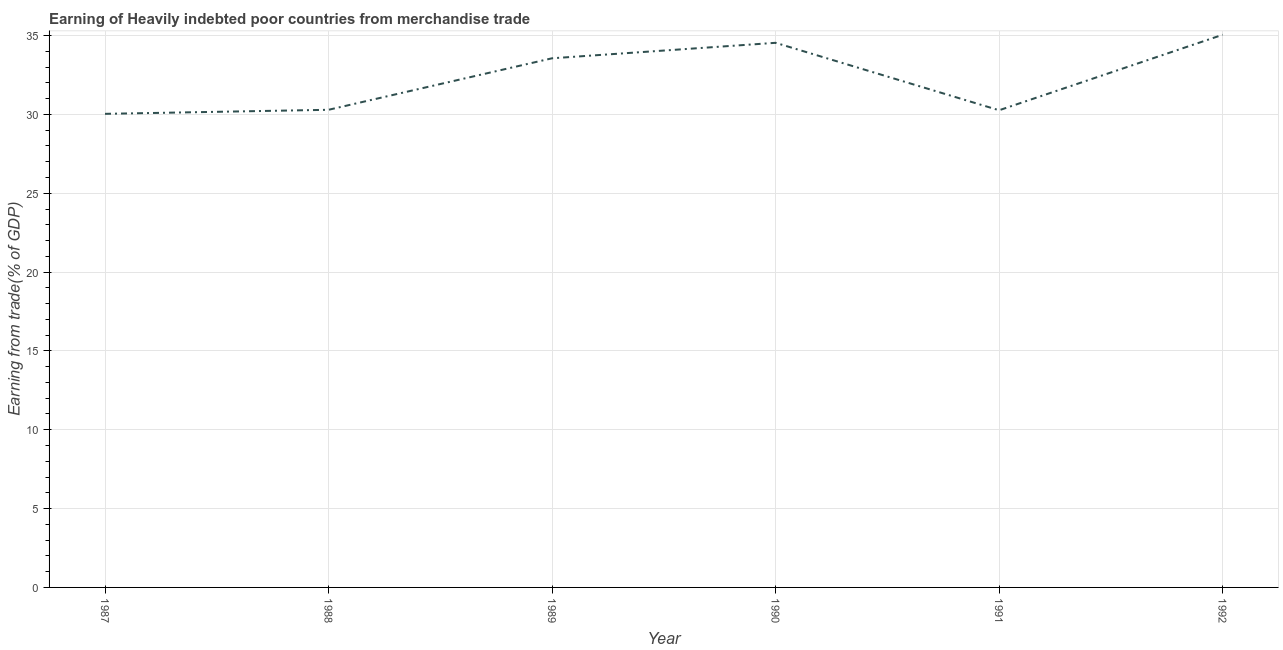What is the earning from merchandise trade in 1991?
Your answer should be very brief. 30.26. Across all years, what is the maximum earning from merchandise trade?
Offer a terse response. 35.05. Across all years, what is the minimum earning from merchandise trade?
Keep it short and to the point. 30.03. In which year was the earning from merchandise trade maximum?
Keep it short and to the point. 1992. In which year was the earning from merchandise trade minimum?
Make the answer very short. 1987. What is the sum of the earning from merchandise trade?
Keep it short and to the point. 193.74. What is the difference between the earning from merchandise trade in 1988 and 1990?
Offer a very short reply. -4.25. What is the average earning from merchandise trade per year?
Your answer should be compact. 32.29. What is the median earning from merchandise trade?
Your answer should be very brief. 31.93. In how many years, is the earning from merchandise trade greater than 25 %?
Make the answer very short. 6. What is the ratio of the earning from merchandise trade in 1988 to that in 1989?
Your response must be concise. 0.9. Is the earning from merchandise trade in 1988 less than that in 1992?
Your answer should be compact. Yes. Is the difference between the earning from merchandise trade in 1987 and 1989 greater than the difference between any two years?
Make the answer very short. No. What is the difference between the highest and the second highest earning from merchandise trade?
Ensure brevity in your answer.  0.51. What is the difference between the highest and the lowest earning from merchandise trade?
Make the answer very short. 5.01. Does the earning from merchandise trade monotonically increase over the years?
Offer a terse response. No. How many years are there in the graph?
Provide a short and direct response. 6. Does the graph contain any zero values?
Offer a terse response. No. What is the title of the graph?
Make the answer very short. Earning of Heavily indebted poor countries from merchandise trade. What is the label or title of the X-axis?
Provide a succinct answer. Year. What is the label or title of the Y-axis?
Ensure brevity in your answer.  Earning from trade(% of GDP). What is the Earning from trade(% of GDP) of 1987?
Offer a terse response. 30.03. What is the Earning from trade(% of GDP) of 1988?
Provide a short and direct response. 30.29. What is the Earning from trade(% of GDP) of 1989?
Provide a short and direct response. 33.56. What is the Earning from trade(% of GDP) of 1990?
Ensure brevity in your answer.  34.54. What is the Earning from trade(% of GDP) of 1991?
Make the answer very short. 30.26. What is the Earning from trade(% of GDP) of 1992?
Provide a succinct answer. 35.05. What is the difference between the Earning from trade(% of GDP) in 1987 and 1988?
Your response must be concise. -0.26. What is the difference between the Earning from trade(% of GDP) in 1987 and 1989?
Your answer should be very brief. -3.52. What is the difference between the Earning from trade(% of GDP) in 1987 and 1990?
Provide a succinct answer. -4.51. What is the difference between the Earning from trade(% of GDP) in 1987 and 1991?
Your response must be concise. -0.23. What is the difference between the Earning from trade(% of GDP) in 1987 and 1992?
Provide a succinct answer. -5.01. What is the difference between the Earning from trade(% of GDP) in 1988 and 1989?
Keep it short and to the point. -3.27. What is the difference between the Earning from trade(% of GDP) in 1988 and 1990?
Give a very brief answer. -4.25. What is the difference between the Earning from trade(% of GDP) in 1988 and 1991?
Offer a terse response. 0.03. What is the difference between the Earning from trade(% of GDP) in 1988 and 1992?
Give a very brief answer. -4.76. What is the difference between the Earning from trade(% of GDP) in 1989 and 1990?
Make the answer very short. -0.98. What is the difference between the Earning from trade(% of GDP) in 1989 and 1991?
Offer a very short reply. 3.3. What is the difference between the Earning from trade(% of GDP) in 1989 and 1992?
Ensure brevity in your answer.  -1.49. What is the difference between the Earning from trade(% of GDP) in 1990 and 1991?
Offer a very short reply. 4.28. What is the difference between the Earning from trade(% of GDP) in 1990 and 1992?
Give a very brief answer. -0.51. What is the difference between the Earning from trade(% of GDP) in 1991 and 1992?
Your answer should be compact. -4.79. What is the ratio of the Earning from trade(% of GDP) in 1987 to that in 1988?
Offer a terse response. 0.99. What is the ratio of the Earning from trade(% of GDP) in 1987 to that in 1989?
Your answer should be compact. 0.9. What is the ratio of the Earning from trade(% of GDP) in 1987 to that in 1990?
Your response must be concise. 0.87. What is the ratio of the Earning from trade(% of GDP) in 1987 to that in 1991?
Keep it short and to the point. 0.99. What is the ratio of the Earning from trade(% of GDP) in 1987 to that in 1992?
Your answer should be very brief. 0.86. What is the ratio of the Earning from trade(% of GDP) in 1988 to that in 1989?
Provide a short and direct response. 0.9. What is the ratio of the Earning from trade(% of GDP) in 1988 to that in 1990?
Keep it short and to the point. 0.88. What is the ratio of the Earning from trade(% of GDP) in 1988 to that in 1992?
Give a very brief answer. 0.86. What is the ratio of the Earning from trade(% of GDP) in 1989 to that in 1990?
Provide a short and direct response. 0.97. What is the ratio of the Earning from trade(% of GDP) in 1989 to that in 1991?
Your answer should be compact. 1.11. What is the ratio of the Earning from trade(% of GDP) in 1989 to that in 1992?
Give a very brief answer. 0.96. What is the ratio of the Earning from trade(% of GDP) in 1990 to that in 1991?
Make the answer very short. 1.14. What is the ratio of the Earning from trade(% of GDP) in 1991 to that in 1992?
Your answer should be compact. 0.86. 